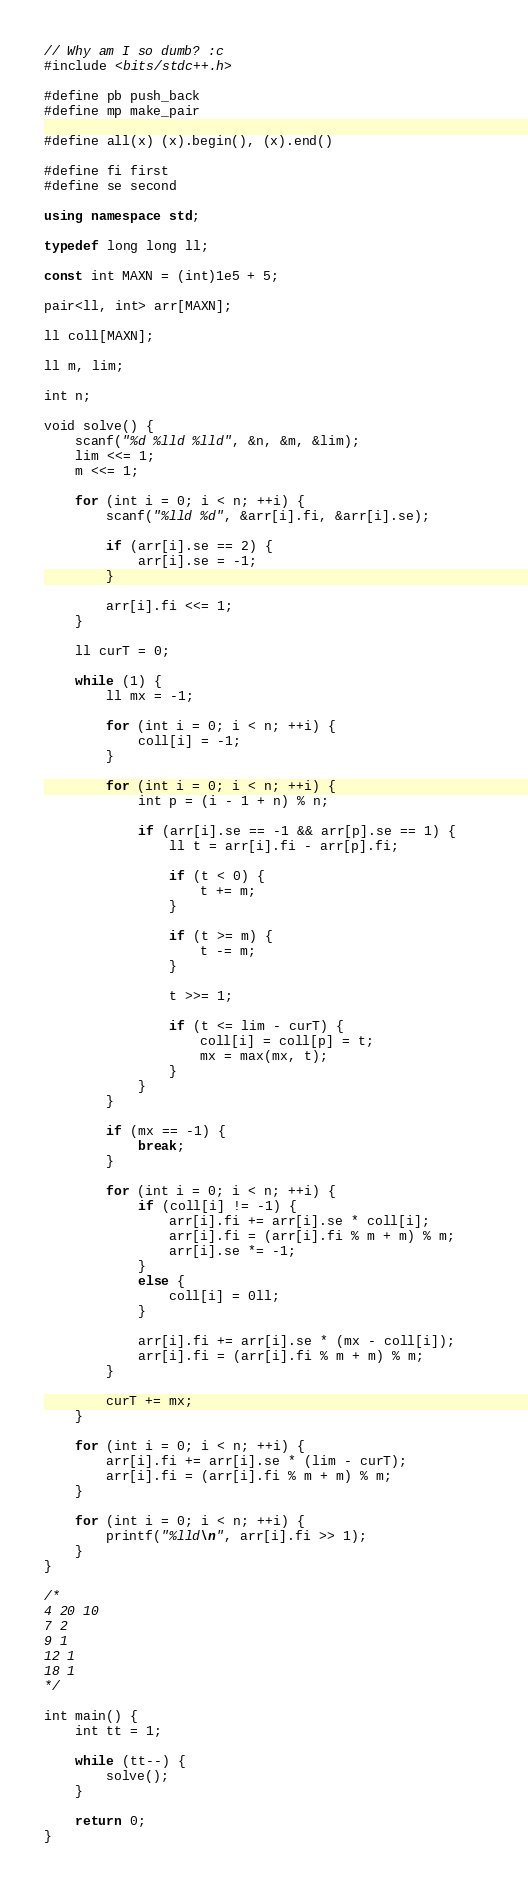<code> <loc_0><loc_0><loc_500><loc_500><_C++_>// Why am I so dumb? :c
#include <bits/stdc++.h>

#define pb push_back
#define mp make_pair

#define all(x) (x).begin(), (x).end()

#define fi first
#define se second

using namespace std;

typedef long long ll;

const int MAXN = (int)1e5 + 5;

pair<ll, int> arr[MAXN];

ll coll[MAXN];

ll m, lim;

int n;

void solve() {                   
	scanf("%d %lld %lld", &n, &m, &lim);
	lim <<= 1;
	m <<= 1;

    for (int i = 0; i < n; ++i) {
    	scanf("%lld %d", &arr[i].fi, &arr[i].se);

    	if (arr[i].se == 2) {
    		arr[i].se = -1;
    	}

    	arr[i].fi <<= 1;
    }

    ll curT = 0;

    while (1) {
    	ll mx = -1;

    	for (int i = 0; i < n; ++i) {
    		coll[i] = -1;
    	}

    	for (int i = 0; i < n; ++i) {
    		int p = (i - 1 + n) % n;

    		if (arr[i].se == -1 && arr[p].se == 1) {
				ll t = arr[i].fi - arr[p].fi;

				if (t < 0) {
					t += m;
				}

				if (t >= m) {
					t -= m;
				}

				t >>= 1;

				if (t <= lim - curT) {
					coll[i] = coll[p] = t;
					mx = max(mx, t);
				}
    		}
    	}

    	if (mx == -1) {
    		break;
    	}

		for (int i = 0; i < n; ++i) {
			if (coll[i] != -1) {						
				arr[i].fi += arr[i].se * coll[i];
				arr[i].fi = (arr[i].fi % m + m) % m;
				arr[i].se *= -1;
			}
			else {
				coll[i] = 0ll;
			}
			
			arr[i].fi += arr[i].se * (mx - coll[i]);
			arr[i].fi = (arr[i].fi % m + m) % m;
		} 

    	curT += mx;
    }

    for (int i = 0; i < n; ++i) {		
		arr[i].fi += arr[i].se * (lim - curT);
		arr[i].fi = (arr[i].fi % m + m) % m;
	}

	for (int i = 0; i < n; ++i) {
		printf("%lld\n", arr[i].fi >> 1);
	}
}

/*
4 20 10
7 2
9 1
12 1
18 1
*/

int main() {    
    int tt = 1;

    while (tt--) {
        solve();
    }

    return 0;
}</code> 